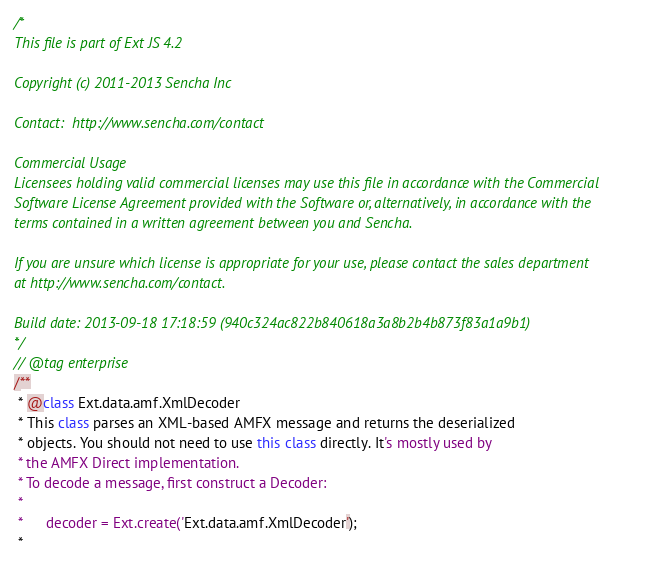Convert code to text. <code><loc_0><loc_0><loc_500><loc_500><_JavaScript_>/*
This file is part of Ext JS 4.2

Copyright (c) 2011-2013 Sencha Inc

Contact:  http://www.sencha.com/contact

Commercial Usage
Licensees holding valid commercial licenses may use this file in accordance with the Commercial
Software License Agreement provided with the Software or, alternatively, in accordance with the
terms contained in a written agreement between you and Sencha.

If you are unsure which license is appropriate for your use, please contact the sales department
at http://www.sencha.com/contact.

Build date: 2013-09-18 17:18:59 (940c324ac822b840618a3a8b2b4b873f83a1a9b1)
*/
// @tag enterprise
/**
 * @class Ext.data.amf.XmlDecoder
 * This class parses an XML-based AMFX message and returns the deserialized
 * objects. You should not need to use this class directly. It's mostly used by
 * the AMFX Direct implementation.
 * To decode a message, first construct a Decoder:
 *
 *      decoder = Ext.create('Ext.data.amf.XmlDecoder');
 *</code> 